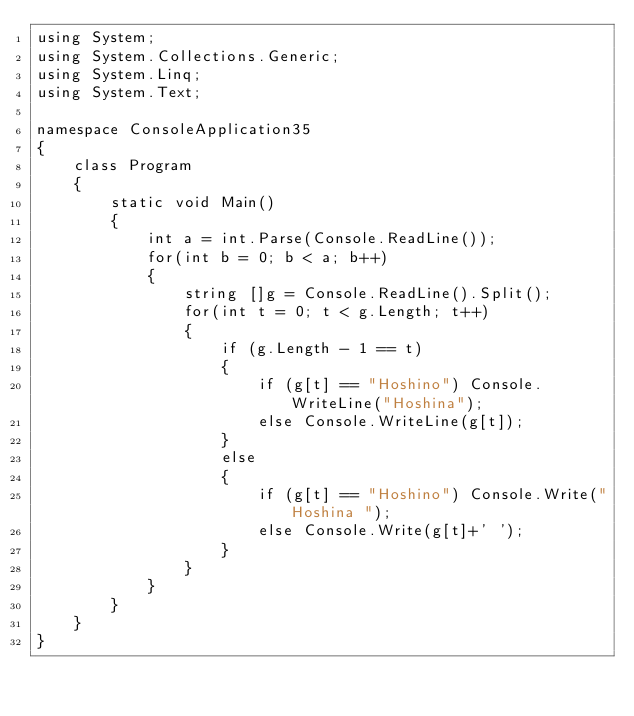Convert code to text. <code><loc_0><loc_0><loc_500><loc_500><_C#_>using System;
using System.Collections.Generic;
using System.Linq;
using System.Text;

namespace ConsoleApplication35
{
    class Program
    {
        static void Main()
        {
            int a = int.Parse(Console.ReadLine());
            for(int b = 0; b < a; b++)
            {
                string []g = Console.ReadLine().Split();
                for(int t = 0; t < g.Length; t++)
                {
                    if (g.Length - 1 == t)
                    {
                        if (g[t] == "Hoshino") Console.WriteLine("Hoshina");
                        else Console.WriteLine(g[t]);
                    }
                    else
                    {
                        if (g[t] == "Hoshino") Console.Write("Hoshina ");
                        else Console.Write(g[t]+' ');
                    }
                }
            }
        }
    }
}</code> 